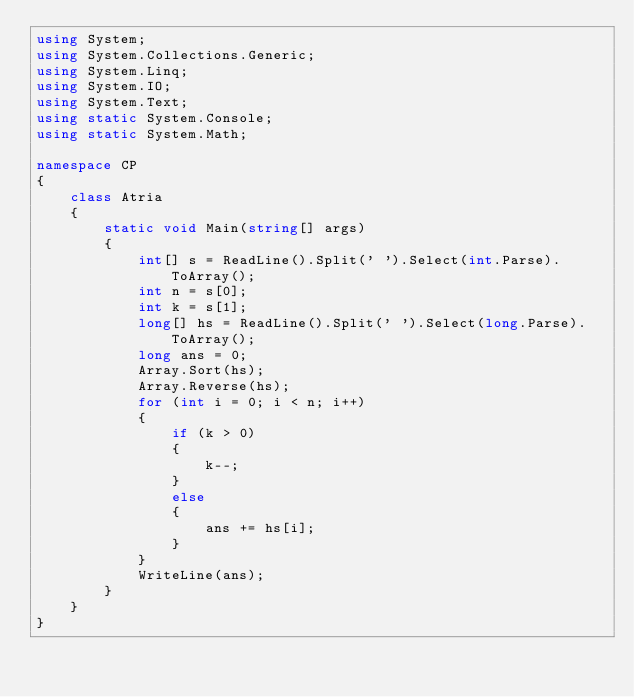<code> <loc_0><loc_0><loc_500><loc_500><_C#_>using System;
using System.Collections.Generic;
using System.Linq;
using System.IO;
using System.Text;
using static System.Console;
using static System.Math;

namespace CP
{
    class Atria
    {
        static void Main(string[] args)
        {
            int[] s = ReadLine().Split(' ').Select(int.Parse).ToArray();
            int n = s[0];
            int k = s[1];
            long[] hs = ReadLine().Split(' ').Select(long.Parse).ToArray();
            long ans = 0;
            Array.Sort(hs);
            Array.Reverse(hs);
            for (int i = 0; i < n; i++)
            {
                if (k > 0)
                {
                    k--;
                }
                else
                {
                    ans += hs[i];
                }
            }
            WriteLine(ans);
        }
    }
}</code> 